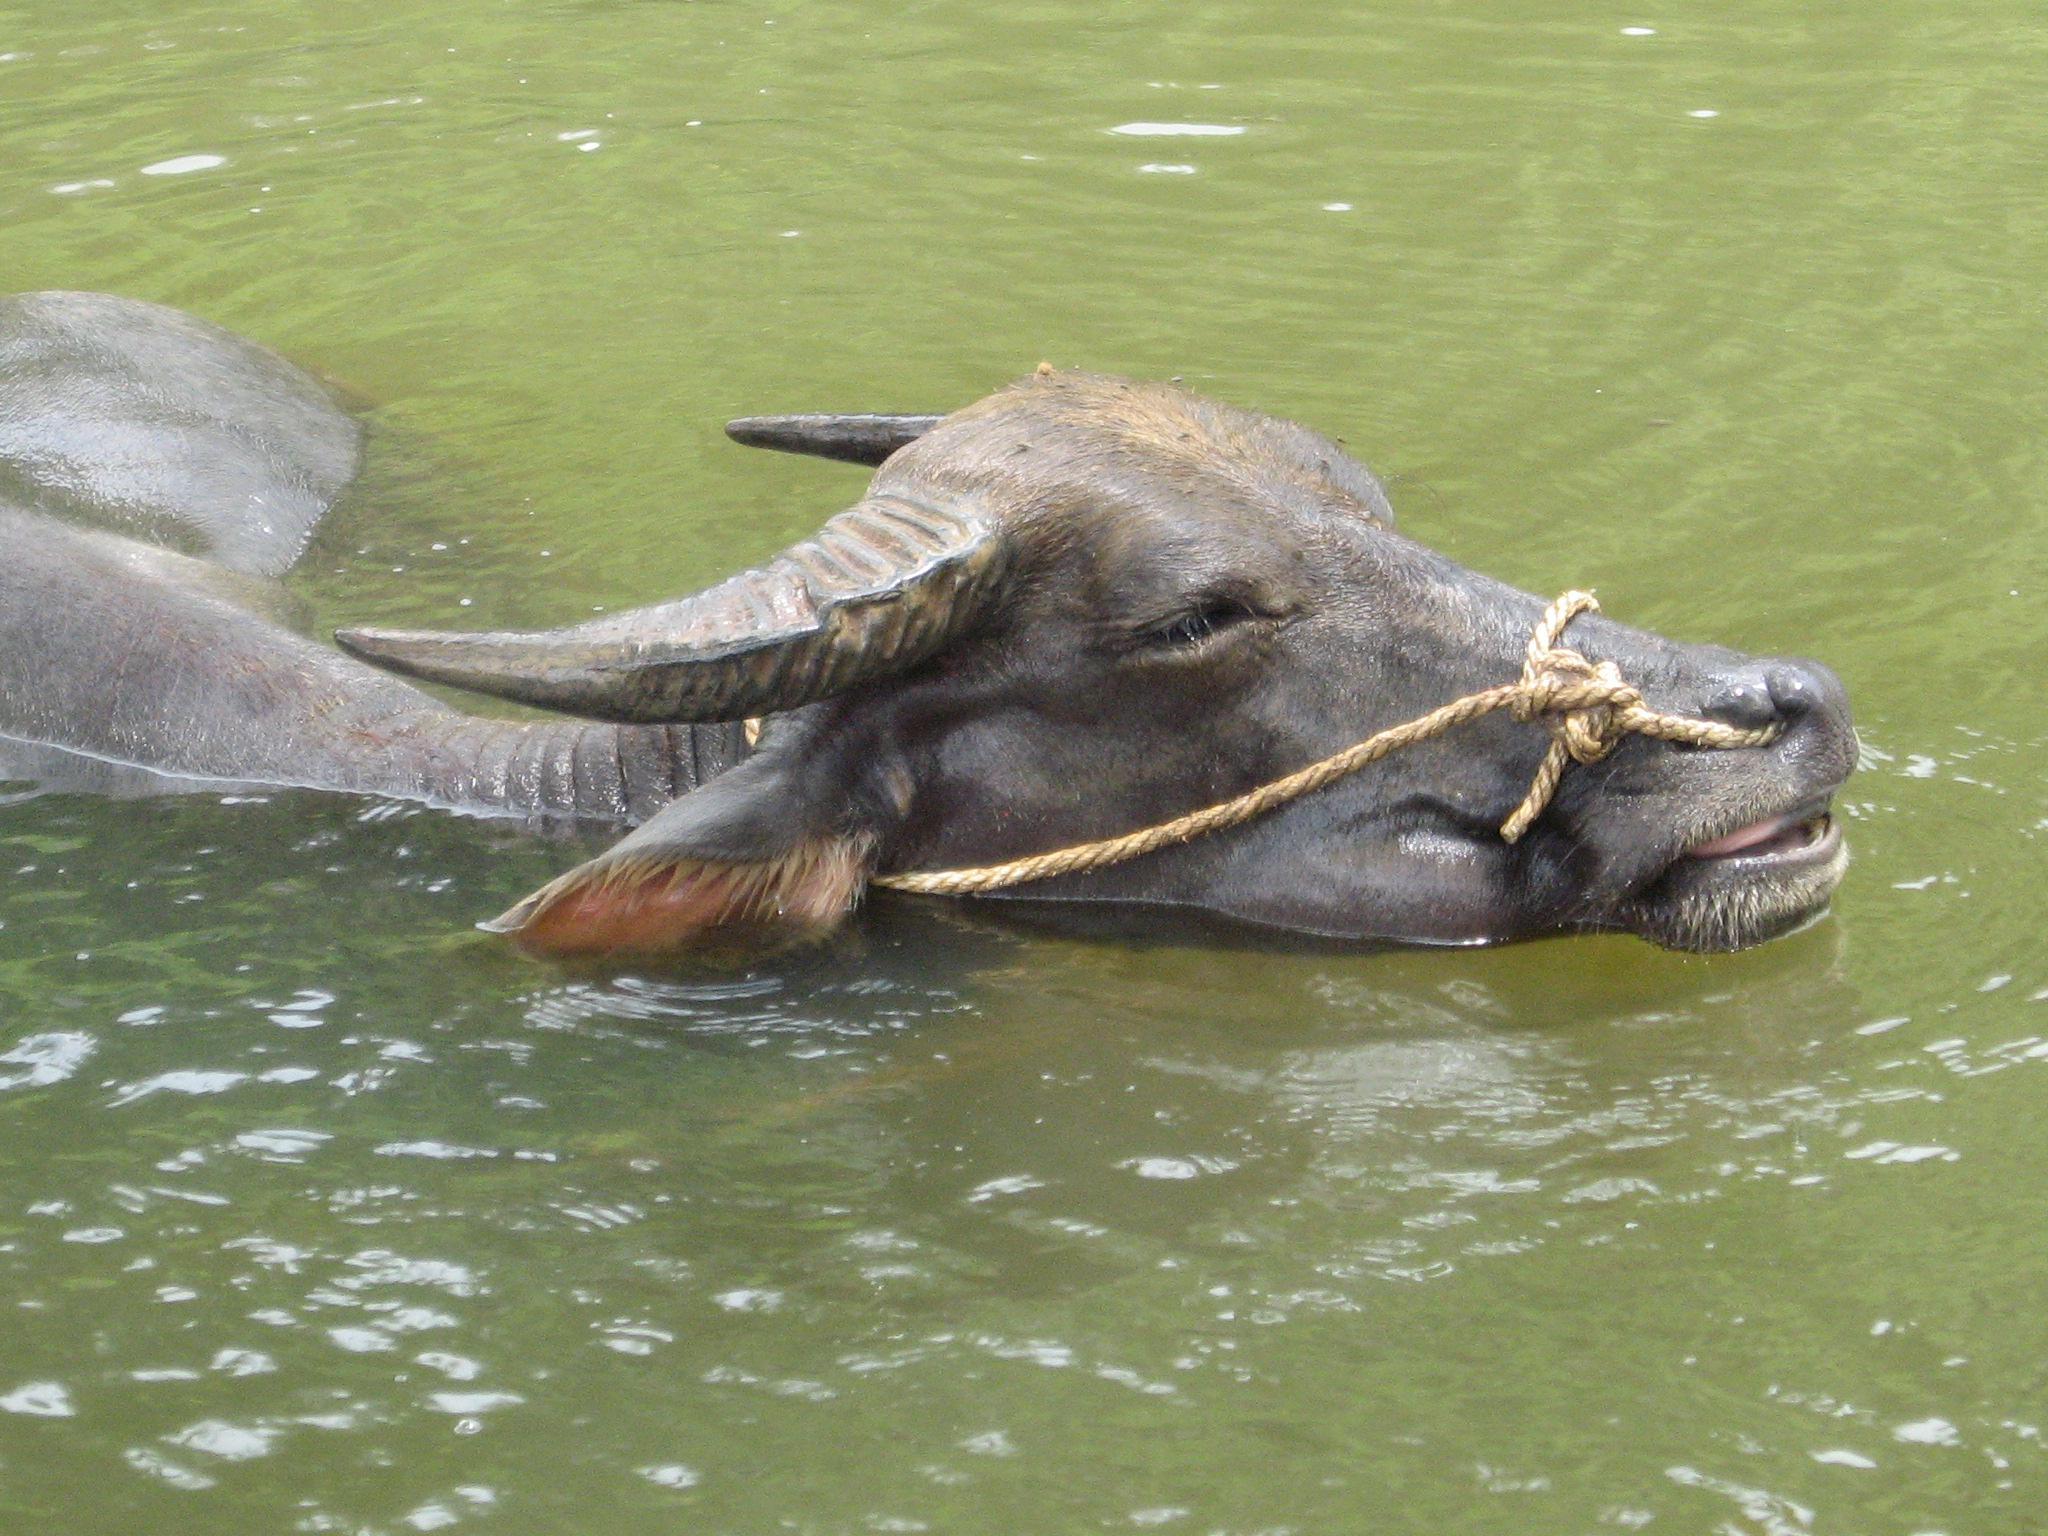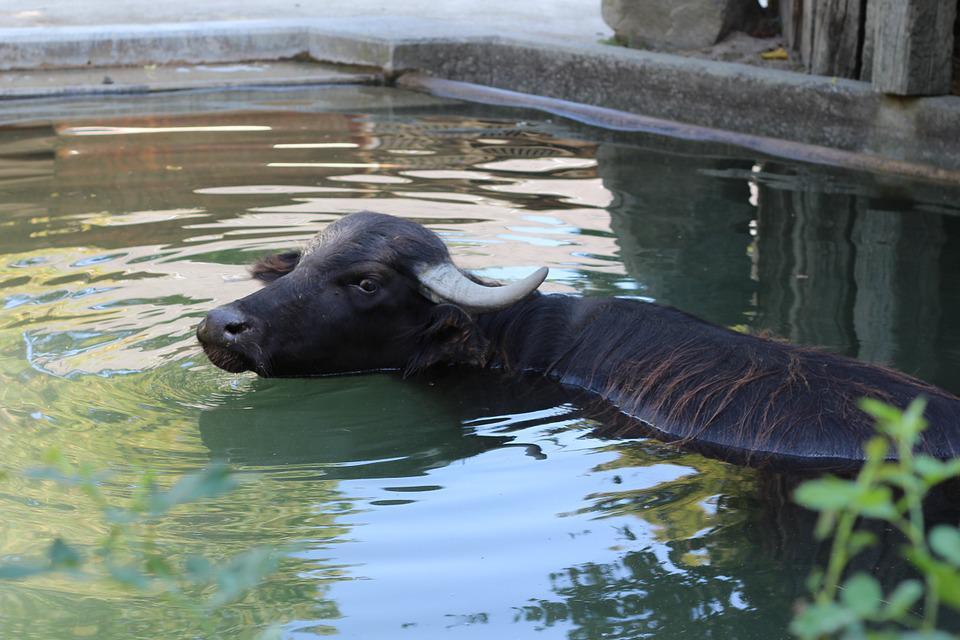The first image is the image on the left, the second image is the image on the right. Given the left and right images, does the statement "The combined images contain no more than three water buffalo, all of them in water to their chins." hold true? Answer yes or no. Yes. The first image is the image on the left, the second image is the image on the right. Examine the images to the left and right. Is the description "The left image contains no more than one water buffalo swimming in water." accurate? Answer yes or no. Yes. 